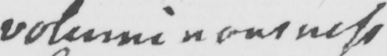Please provide the text content of this handwritten line. voluminousness 